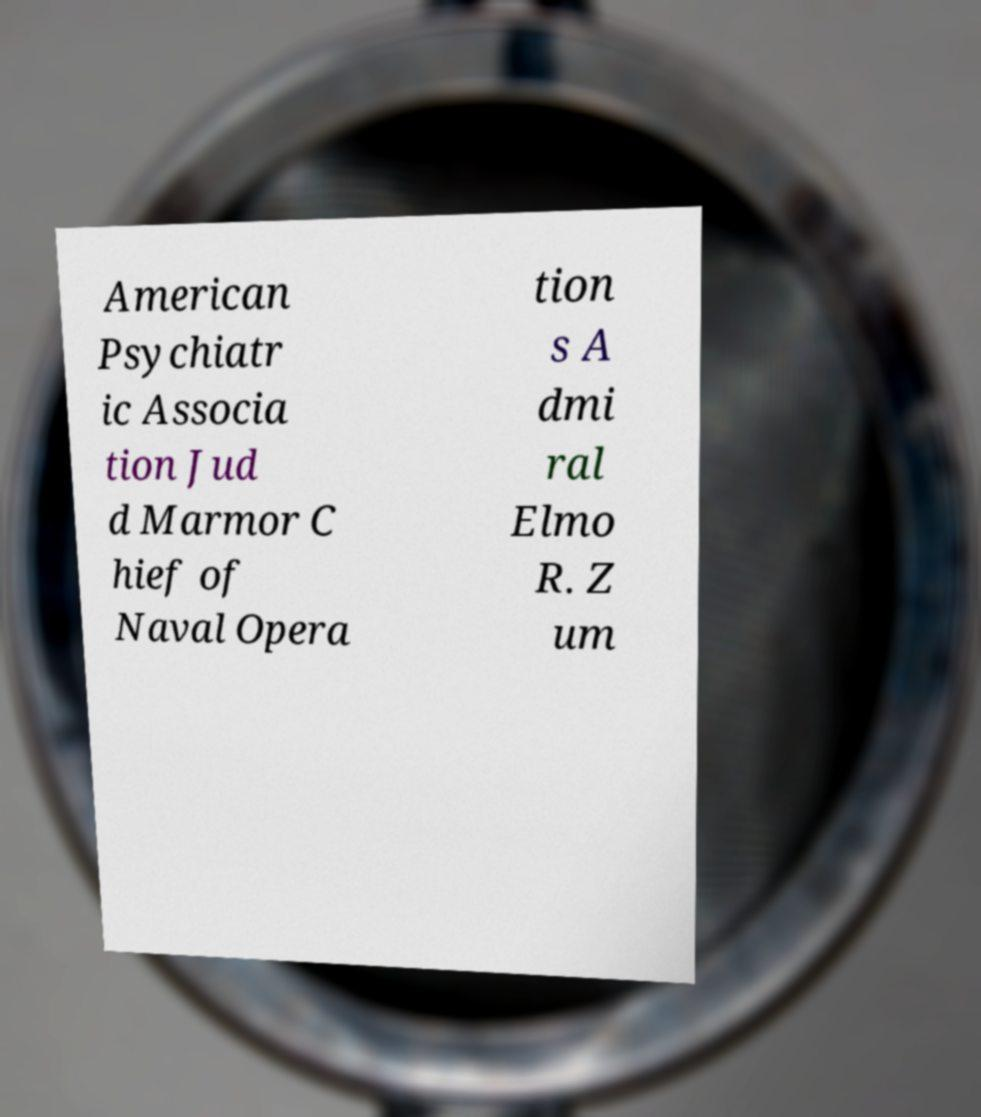Please read and relay the text visible in this image. What does it say? American Psychiatr ic Associa tion Jud d Marmor C hief of Naval Opera tion s A dmi ral Elmo R. Z um 